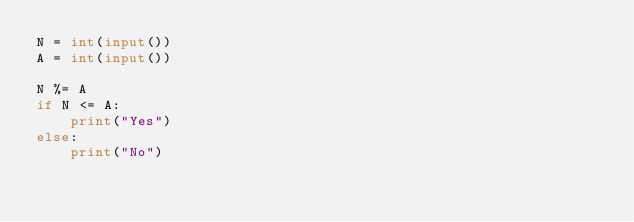<code> <loc_0><loc_0><loc_500><loc_500><_Python_>N = int(input())
A = int(input())

N %= A
if N <= A:
    print("Yes")
else:
    print("No")</code> 